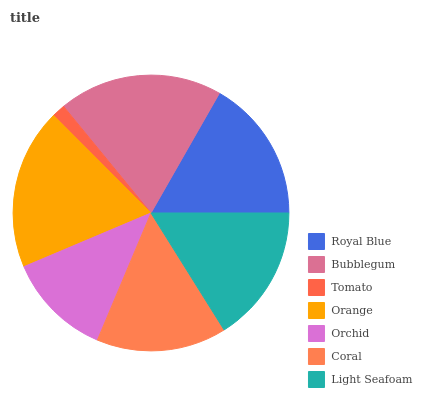Is Tomato the minimum?
Answer yes or no. Yes. Is Bubblegum the maximum?
Answer yes or no. Yes. Is Bubblegum the minimum?
Answer yes or no. No. Is Tomato the maximum?
Answer yes or no. No. Is Bubblegum greater than Tomato?
Answer yes or no. Yes. Is Tomato less than Bubblegum?
Answer yes or no. Yes. Is Tomato greater than Bubblegum?
Answer yes or no. No. Is Bubblegum less than Tomato?
Answer yes or no. No. Is Light Seafoam the high median?
Answer yes or no. Yes. Is Light Seafoam the low median?
Answer yes or no. Yes. Is Orchid the high median?
Answer yes or no. No. Is Royal Blue the low median?
Answer yes or no. No. 